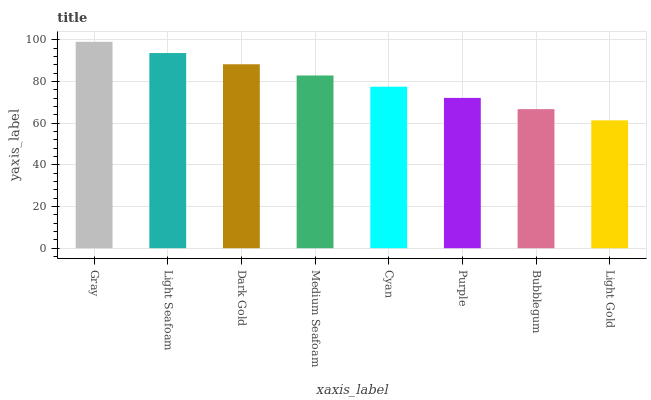Is Light Seafoam the minimum?
Answer yes or no. No. Is Light Seafoam the maximum?
Answer yes or no. No. Is Gray greater than Light Seafoam?
Answer yes or no. Yes. Is Light Seafoam less than Gray?
Answer yes or no. Yes. Is Light Seafoam greater than Gray?
Answer yes or no. No. Is Gray less than Light Seafoam?
Answer yes or no. No. Is Medium Seafoam the high median?
Answer yes or no. Yes. Is Cyan the low median?
Answer yes or no. Yes. Is Bubblegum the high median?
Answer yes or no. No. Is Light Seafoam the low median?
Answer yes or no. No. 